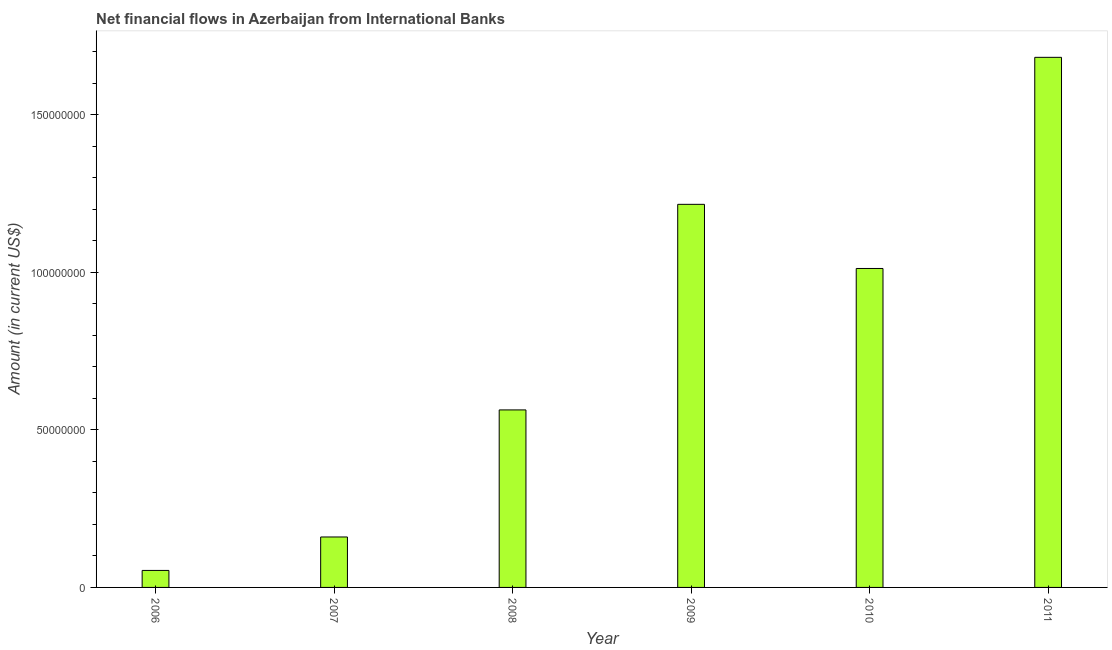Does the graph contain any zero values?
Give a very brief answer. No. Does the graph contain grids?
Make the answer very short. No. What is the title of the graph?
Provide a succinct answer. Net financial flows in Azerbaijan from International Banks. What is the label or title of the X-axis?
Your answer should be very brief. Year. What is the net financial flows from ibrd in 2009?
Keep it short and to the point. 1.22e+08. Across all years, what is the maximum net financial flows from ibrd?
Offer a terse response. 1.68e+08. Across all years, what is the minimum net financial flows from ibrd?
Offer a terse response. 5.39e+06. In which year was the net financial flows from ibrd minimum?
Your answer should be very brief. 2006. What is the sum of the net financial flows from ibrd?
Offer a terse response. 4.69e+08. What is the difference between the net financial flows from ibrd in 2008 and 2010?
Offer a terse response. -4.49e+07. What is the average net financial flows from ibrd per year?
Your answer should be very brief. 7.81e+07. What is the median net financial flows from ibrd?
Offer a terse response. 7.88e+07. Do a majority of the years between 2009 and 2007 (inclusive) have net financial flows from ibrd greater than 60000000 US$?
Offer a terse response. Yes. What is the ratio of the net financial flows from ibrd in 2007 to that in 2009?
Give a very brief answer. 0.13. Is the net financial flows from ibrd in 2006 less than that in 2010?
Keep it short and to the point. Yes. Is the difference between the net financial flows from ibrd in 2006 and 2011 greater than the difference between any two years?
Your answer should be compact. Yes. What is the difference between the highest and the second highest net financial flows from ibrd?
Your answer should be very brief. 4.66e+07. Is the sum of the net financial flows from ibrd in 2009 and 2011 greater than the maximum net financial flows from ibrd across all years?
Provide a short and direct response. Yes. What is the difference between the highest and the lowest net financial flows from ibrd?
Keep it short and to the point. 1.63e+08. In how many years, is the net financial flows from ibrd greater than the average net financial flows from ibrd taken over all years?
Keep it short and to the point. 3. How many bars are there?
Provide a succinct answer. 6. Are all the bars in the graph horizontal?
Give a very brief answer. No. What is the difference between two consecutive major ticks on the Y-axis?
Provide a short and direct response. 5.00e+07. Are the values on the major ticks of Y-axis written in scientific E-notation?
Offer a very short reply. No. What is the Amount (in current US$) of 2006?
Provide a succinct answer. 5.39e+06. What is the Amount (in current US$) in 2007?
Offer a terse response. 1.60e+07. What is the Amount (in current US$) in 2008?
Provide a short and direct response. 5.63e+07. What is the Amount (in current US$) in 2009?
Offer a terse response. 1.22e+08. What is the Amount (in current US$) of 2010?
Your answer should be compact. 1.01e+08. What is the Amount (in current US$) of 2011?
Ensure brevity in your answer.  1.68e+08. What is the difference between the Amount (in current US$) in 2006 and 2007?
Provide a short and direct response. -1.06e+07. What is the difference between the Amount (in current US$) in 2006 and 2008?
Provide a short and direct response. -5.09e+07. What is the difference between the Amount (in current US$) in 2006 and 2009?
Your answer should be very brief. -1.16e+08. What is the difference between the Amount (in current US$) in 2006 and 2010?
Provide a succinct answer. -9.58e+07. What is the difference between the Amount (in current US$) in 2006 and 2011?
Offer a terse response. -1.63e+08. What is the difference between the Amount (in current US$) in 2007 and 2008?
Provide a succinct answer. -4.03e+07. What is the difference between the Amount (in current US$) in 2007 and 2009?
Offer a terse response. -1.06e+08. What is the difference between the Amount (in current US$) in 2007 and 2010?
Your answer should be very brief. -8.52e+07. What is the difference between the Amount (in current US$) in 2007 and 2011?
Offer a very short reply. -1.52e+08. What is the difference between the Amount (in current US$) in 2008 and 2009?
Give a very brief answer. -6.52e+07. What is the difference between the Amount (in current US$) in 2008 and 2010?
Ensure brevity in your answer.  -4.49e+07. What is the difference between the Amount (in current US$) in 2008 and 2011?
Provide a short and direct response. -1.12e+08. What is the difference between the Amount (in current US$) in 2009 and 2010?
Your answer should be very brief. 2.04e+07. What is the difference between the Amount (in current US$) in 2009 and 2011?
Your response must be concise. -4.66e+07. What is the difference between the Amount (in current US$) in 2010 and 2011?
Provide a succinct answer. -6.70e+07. What is the ratio of the Amount (in current US$) in 2006 to that in 2007?
Offer a terse response. 0.34. What is the ratio of the Amount (in current US$) in 2006 to that in 2008?
Provide a succinct answer. 0.1. What is the ratio of the Amount (in current US$) in 2006 to that in 2009?
Your answer should be compact. 0.04. What is the ratio of the Amount (in current US$) in 2006 to that in 2010?
Ensure brevity in your answer.  0.05. What is the ratio of the Amount (in current US$) in 2006 to that in 2011?
Ensure brevity in your answer.  0.03. What is the ratio of the Amount (in current US$) in 2007 to that in 2008?
Make the answer very short. 0.28. What is the ratio of the Amount (in current US$) in 2007 to that in 2009?
Your answer should be very brief. 0.13. What is the ratio of the Amount (in current US$) in 2007 to that in 2010?
Your response must be concise. 0.16. What is the ratio of the Amount (in current US$) in 2007 to that in 2011?
Keep it short and to the point. 0.1. What is the ratio of the Amount (in current US$) in 2008 to that in 2009?
Provide a succinct answer. 0.46. What is the ratio of the Amount (in current US$) in 2008 to that in 2010?
Ensure brevity in your answer.  0.56. What is the ratio of the Amount (in current US$) in 2008 to that in 2011?
Your answer should be compact. 0.34. What is the ratio of the Amount (in current US$) in 2009 to that in 2010?
Your response must be concise. 1.2. What is the ratio of the Amount (in current US$) in 2009 to that in 2011?
Ensure brevity in your answer.  0.72. What is the ratio of the Amount (in current US$) in 2010 to that in 2011?
Give a very brief answer. 0.6. 